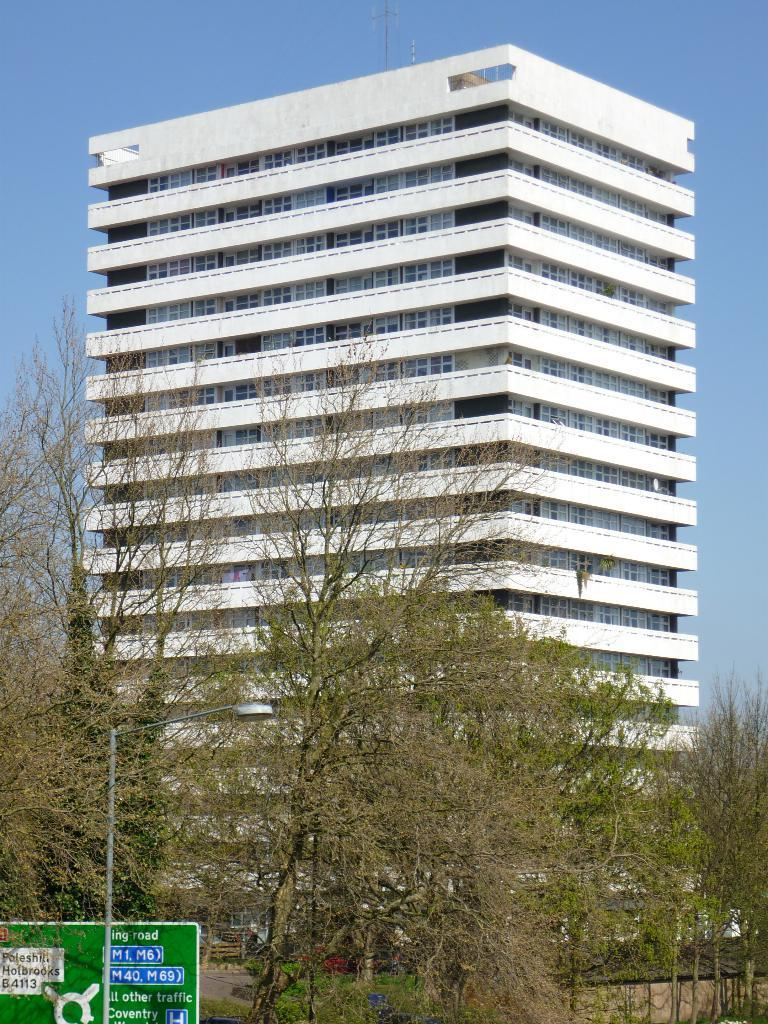What type of structure is present in the image? There is a building in the image. What is attached to the building? There is a pole in the image, which is attached to the building. What is illuminating the area in the image? There is a light in the image, which provides illumination. What is displayed on the pole? There is a board in the image, which is attached to the pole. What type of vegetation is visible in the image? There are trees in the image. What type of sky is visible in the background of the image? The sky is visible in the background of the image, but the facts do not specify the type of sky. How many tents are set up in the image? There are no tents present in the image. What type of ornament is hanging from the light in the image? There is no ornament hanging from the light in the image. 